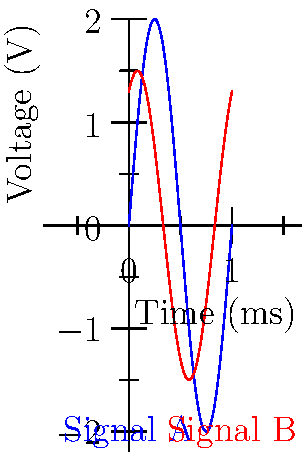As an illustrator working on a technical manual for oscilloscopes, you've been given the task of interpreting the voltage-time graph shown above. What is the phase difference between Signal A (blue) and Signal B (red)? To find the phase difference between the two signals, we need to follow these steps:

1. Identify the period of the signals:
   Both signals complete one full cycle in 1 ms, so the period $T = 1$ ms.

2. Calculate the angular frequency $\omega$:
   $\omega = \frac{2\pi}{T} = \frac{2\pi}{1\text{ ms}} = 2\pi \text{ rad/ms}$

3. Express the signals mathematically:
   Signal A: $V_A(t) = 2\sin(2\pi t)$
   Signal B: $V_B(t) = 1.5\sin(2\pi t + \phi)$, where $\phi$ is the phase difference we're looking for.

4. Observe the time shift between the signals:
   Signal B appears to be shifted to the left by 1/6 of the period.

5. Calculate the phase difference:
   $\phi = \frac{1}{6} \cdot 2\pi = \frac{\pi}{3} \text{ rad}$

6. Convert to degrees:
   $\phi = \frac{\pi}{3} \cdot \frac{180°}{\pi} = 60°$

Therefore, the phase difference between Signal A and Signal B is $\frac{\pi}{3}$ radians or 60°.
Answer: $\frac{\pi}{3}$ rad or 60° 